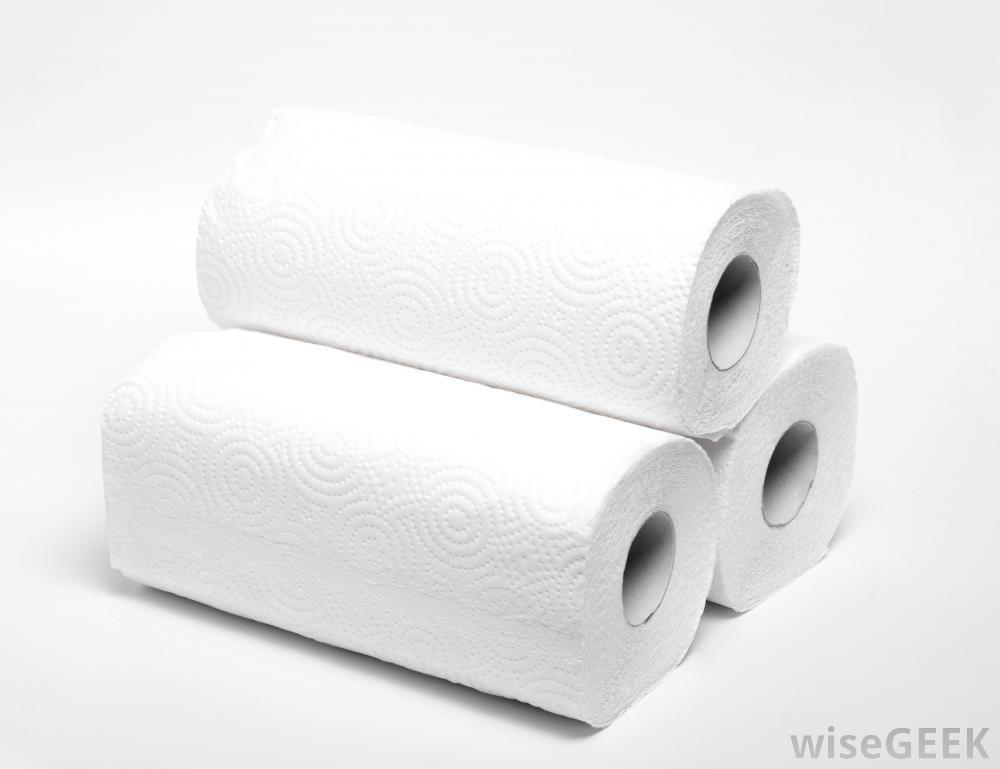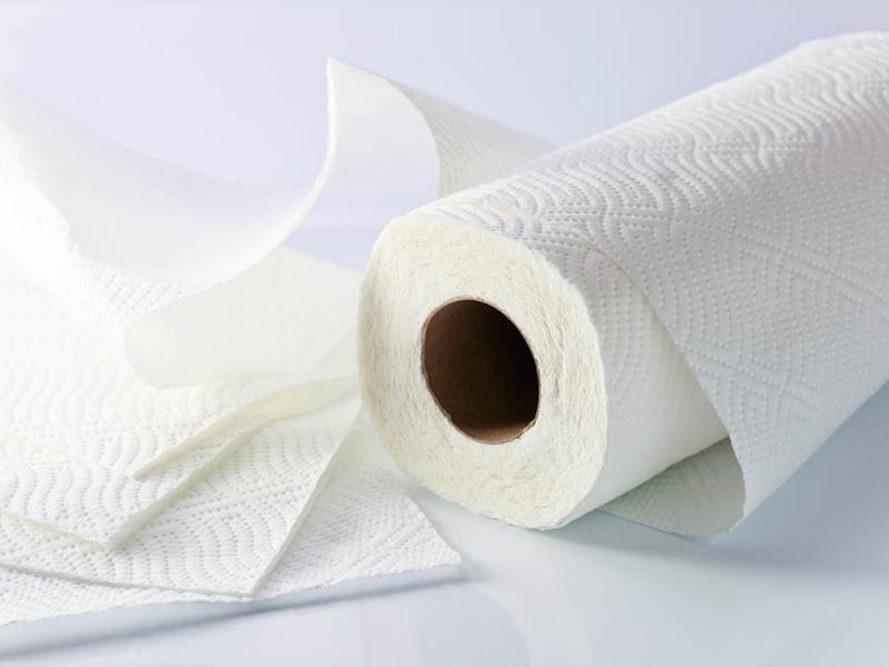The first image is the image on the left, the second image is the image on the right. Analyze the images presented: Is the assertion "The left image contains at least five paper rolls." valid? Answer yes or no. No. 